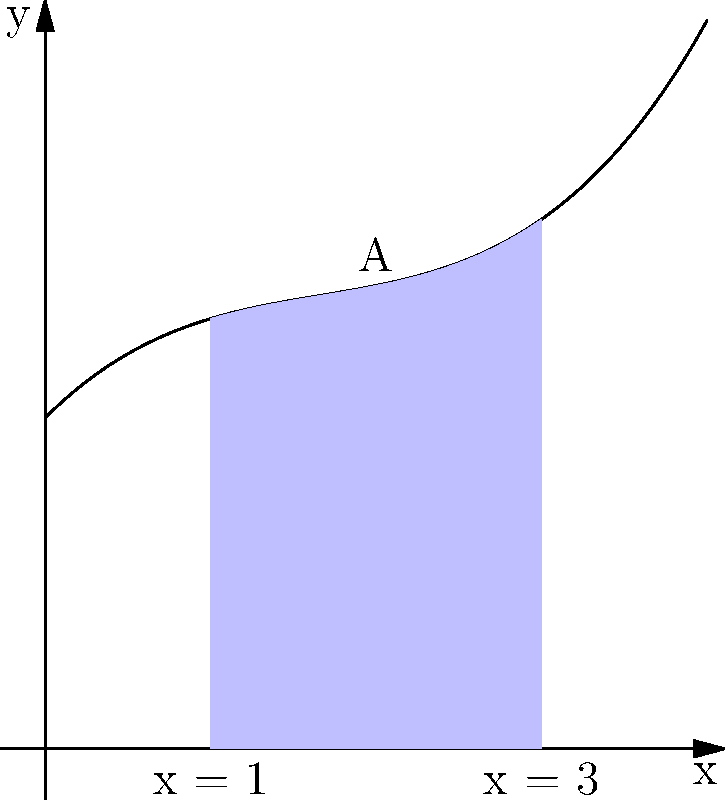A vintage brooch design is represented by the polynomial function $f(x) = 0.1x^3 - 0.5x^2 + x + 2$, where $x$ is measured in centimeters. Calculate the area of the brooch design between $x = 1$ and $x = 3$, as shown in the shaded region A in the graph. Round your answer to two decimal places. To find the area under the curve between $x = 1$ and $x = 3$, we need to calculate the definite integral of the function $f(x)$ from 1 to 3.

1) The integral of $f(x) = 0.1x^3 - 0.5x^2 + x + 2$ is:
   $F(x) = 0.025x^4 - \frac{1}{6}x^3 + \frac{1}{2}x^2 + 2x + C$

2) We need to calculate $\int_1^3 f(x) dx = F(3) - F(1)$

3) $F(3) = 0.025(3^4) - \frac{1}{6}(3^3) + \frac{1}{2}(3^2) + 2(3)$
         $= 2.025 - 4.5 + 4.5 + 6 = 8.025$

4) $F(1) = 0.025(1^4) - \frac{1}{6}(1^3) + \frac{1}{2}(1^2) + 2(1)$
         $= 0.025 - \frac{1}{6} + 0.5 + 2 = 2.3583$

5) Area $= F(3) - F(1) = 8.025 - 2.3583 = 5.6667$

6) Rounding to two decimal places: 5.67 cm²
Answer: 5.67 cm² 